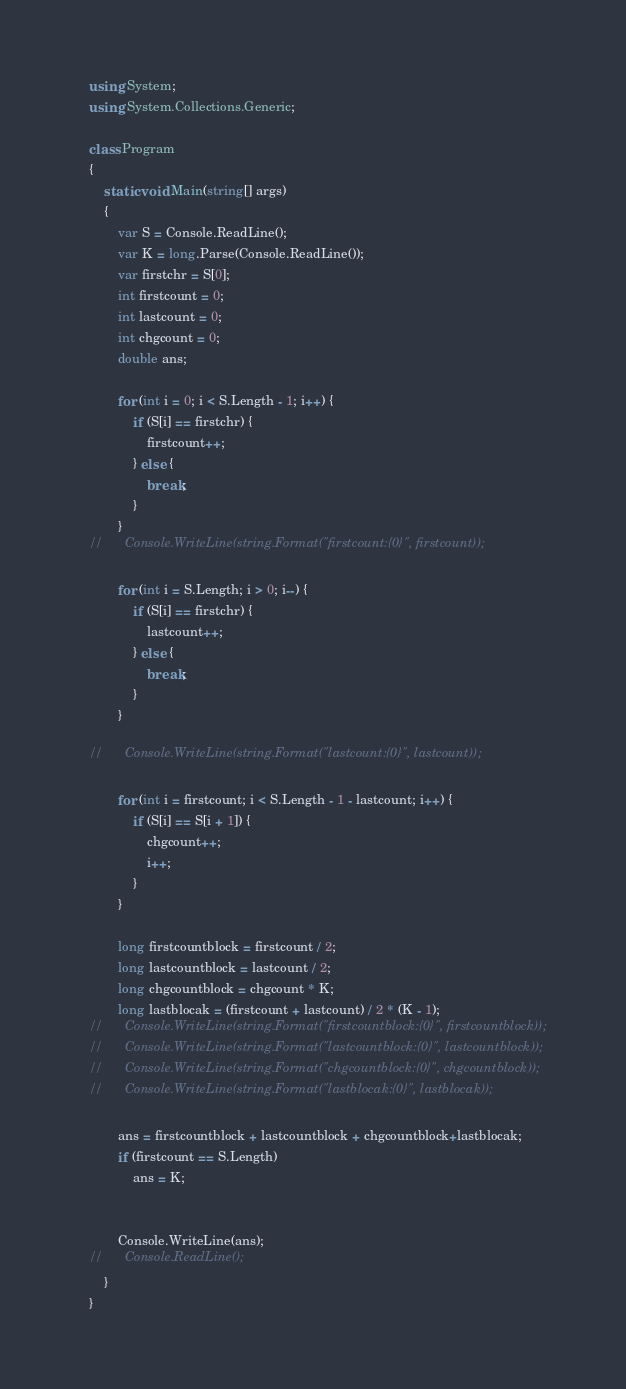Convert code to text. <code><loc_0><loc_0><loc_500><loc_500><_C#_>    using System;
    using System.Collections.Generic;
     
    class Program
    {
    	static void Main(string[] args)
    	{
    		var S = Console.ReadLine();
    		var K = long.Parse(Console.ReadLine());
    		var firstchr = S[0];
    		int firstcount = 0;
    		int lastcount = 0;
    		int chgcount = 0;
    		double ans;
    		
    		for (int i = 0; i < S.Length - 1; i++) {
    			if (S[i] == firstchr) {
    				firstcount++;
    			} else {
    				break;
    			}
    		}
    //		Console.WriteLine(string.Format("firstcount:{0}", firstcount));
    		
    		for (int i = S.Length; i > 0; i--) {
    			if (S[i] == firstchr) {
    				lastcount++;
    			} else {
    				break;
    			}
    		}
     
    //		Console.WriteLine(string.Format("lastcount:{0}", lastcount));
    		
    		for (int i = firstcount; i < S.Length - 1 - lastcount; i++) {
    			if (S[i] == S[i + 1]) {
    				chgcount++;
    				i++;
    			}
    		}
    		
    		long firstcountblock = firstcount / 2;
    		long lastcountblock = lastcount / 2;
    		long chgcountblock = chgcount * K;
    		long lastblocak = (firstcount + lastcount) / 2 * (K - 1);
    //		Console.WriteLine(string.Format("firstcountblock:{0}", firstcountblock));
    //		Console.WriteLine(string.Format("lastcountblock:{0}", lastcountblock));
    //		Console.WriteLine(string.Format("chgcountblock:{0}", chgcountblock));
    //		Console.WriteLine(string.Format("lastblocak:{0}", lastblocak));
    		
    		ans = firstcountblock + lastcountblock + chgcountblock+lastblocak;
    		if (firstcount == S.Length)
    			ans = K;
     
     
    		Console.WriteLine(ans);
    //		Console.ReadLine();
    	}
    }</code> 